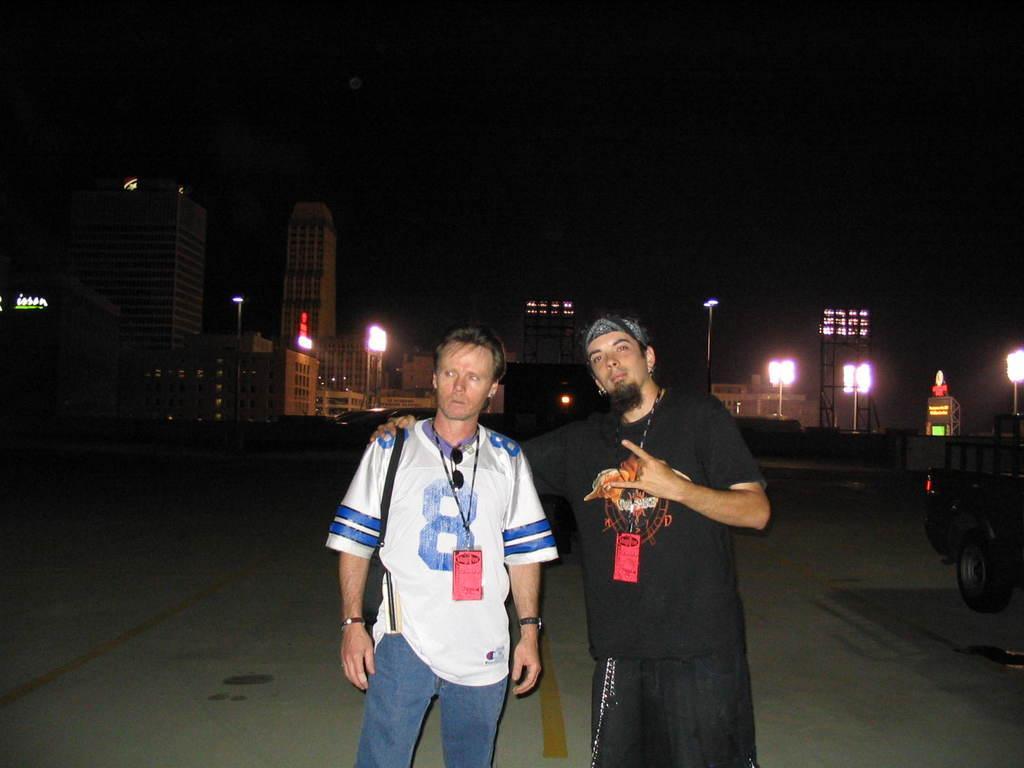Could you give a brief overview of what you see in this image? In this image we can see two men standing on the road. We can also see a vehicle beside them. On the backside we can see a group of buildings, some lights, the metal frames, poles and the sky. 